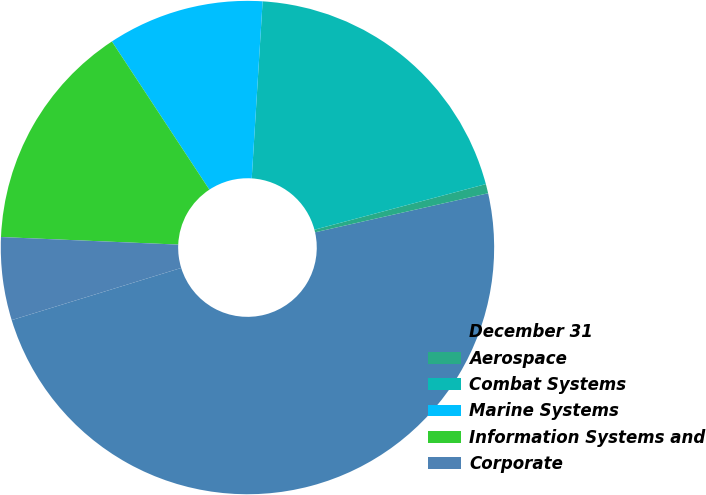Convert chart to OTSL. <chart><loc_0><loc_0><loc_500><loc_500><pie_chart><fcel>December 31<fcel>Aerospace<fcel>Combat Systems<fcel>Marine Systems<fcel>Information Systems and<fcel>Corporate<nl><fcel>48.78%<fcel>0.61%<fcel>19.88%<fcel>10.24%<fcel>15.06%<fcel>5.43%<nl></chart> 